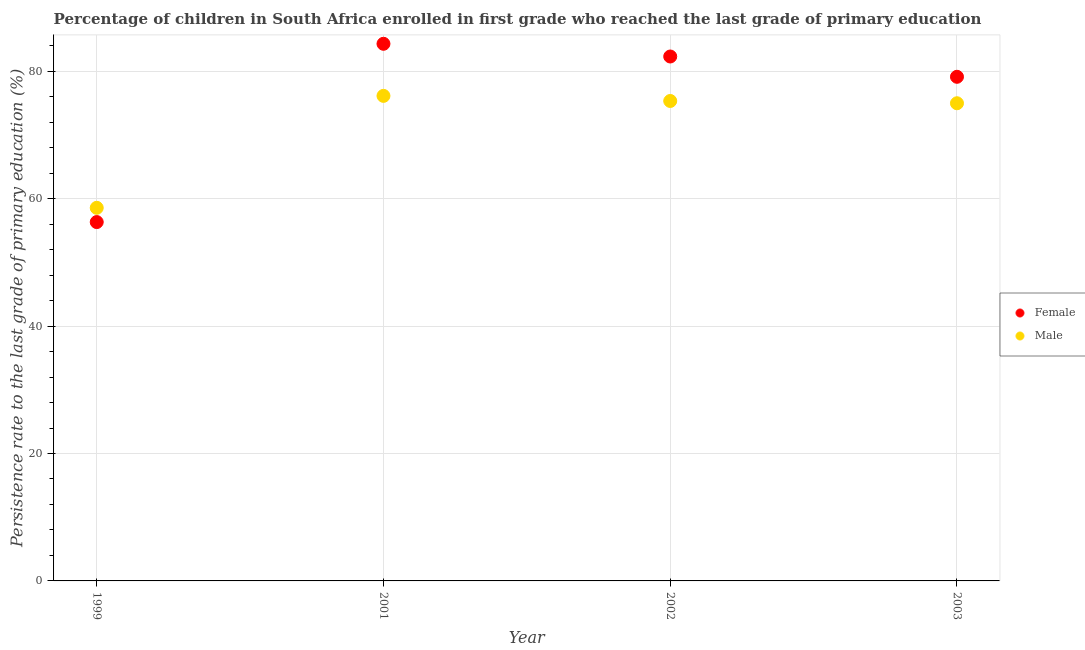How many different coloured dotlines are there?
Your answer should be very brief. 2. Is the number of dotlines equal to the number of legend labels?
Offer a terse response. Yes. What is the persistence rate of female students in 2001?
Your answer should be compact. 84.32. Across all years, what is the maximum persistence rate of female students?
Your response must be concise. 84.32. Across all years, what is the minimum persistence rate of female students?
Give a very brief answer. 56.33. What is the total persistence rate of male students in the graph?
Your answer should be very brief. 285.03. What is the difference between the persistence rate of male students in 2001 and that in 2002?
Give a very brief answer. 0.8. What is the difference between the persistence rate of male students in 1999 and the persistence rate of female students in 2002?
Your response must be concise. -23.75. What is the average persistence rate of male students per year?
Offer a very short reply. 71.26. In the year 2002, what is the difference between the persistence rate of female students and persistence rate of male students?
Provide a short and direct response. 6.98. What is the ratio of the persistence rate of female students in 1999 to that in 2001?
Provide a short and direct response. 0.67. Is the persistence rate of female students in 1999 less than that in 2001?
Your answer should be compact. Yes. Is the difference between the persistence rate of male students in 1999 and 2003 greater than the difference between the persistence rate of female students in 1999 and 2003?
Ensure brevity in your answer.  Yes. What is the difference between the highest and the second highest persistence rate of female students?
Your answer should be very brief. 2. What is the difference between the highest and the lowest persistence rate of male students?
Ensure brevity in your answer.  17.57. In how many years, is the persistence rate of female students greater than the average persistence rate of female students taken over all years?
Provide a succinct answer. 3. Is the persistence rate of female students strictly less than the persistence rate of male students over the years?
Give a very brief answer. No. What is the difference between two consecutive major ticks on the Y-axis?
Your response must be concise. 20. Are the values on the major ticks of Y-axis written in scientific E-notation?
Offer a terse response. No. Does the graph contain grids?
Your response must be concise. Yes. How many legend labels are there?
Your answer should be very brief. 2. How are the legend labels stacked?
Offer a terse response. Vertical. What is the title of the graph?
Your answer should be very brief. Percentage of children in South Africa enrolled in first grade who reached the last grade of primary education. Does "Male labor force" appear as one of the legend labels in the graph?
Make the answer very short. No. What is the label or title of the X-axis?
Provide a short and direct response. Year. What is the label or title of the Y-axis?
Offer a very short reply. Persistence rate to the last grade of primary education (%). What is the Persistence rate to the last grade of primary education (%) in Female in 1999?
Provide a succinct answer. 56.33. What is the Persistence rate to the last grade of primary education (%) of Male in 1999?
Offer a terse response. 58.57. What is the Persistence rate to the last grade of primary education (%) in Female in 2001?
Your answer should be compact. 84.32. What is the Persistence rate to the last grade of primary education (%) of Male in 2001?
Your answer should be very brief. 76.14. What is the Persistence rate to the last grade of primary education (%) of Female in 2002?
Your response must be concise. 82.32. What is the Persistence rate to the last grade of primary education (%) of Male in 2002?
Your answer should be compact. 75.34. What is the Persistence rate to the last grade of primary education (%) of Female in 2003?
Your answer should be compact. 79.13. What is the Persistence rate to the last grade of primary education (%) in Male in 2003?
Keep it short and to the point. 74.98. Across all years, what is the maximum Persistence rate to the last grade of primary education (%) of Female?
Provide a short and direct response. 84.32. Across all years, what is the maximum Persistence rate to the last grade of primary education (%) in Male?
Provide a succinct answer. 76.14. Across all years, what is the minimum Persistence rate to the last grade of primary education (%) in Female?
Provide a short and direct response. 56.33. Across all years, what is the minimum Persistence rate to the last grade of primary education (%) in Male?
Provide a short and direct response. 58.57. What is the total Persistence rate to the last grade of primary education (%) in Female in the graph?
Make the answer very short. 302.1. What is the total Persistence rate to the last grade of primary education (%) in Male in the graph?
Make the answer very short. 285.03. What is the difference between the Persistence rate to the last grade of primary education (%) in Female in 1999 and that in 2001?
Offer a terse response. -27.99. What is the difference between the Persistence rate to the last grade of primary education (%) of Male in 1999 and that in 2001?
Keep it short and to the point. -17.57. What is the difference between the Persistence rate to the last grade of primary education (%) of Female in 1999 and that in 2002?
Make the answer very short. -25.99. What is the difference between the Persistence rate to the last grade of primary education (%) of Male in 1999 and that in 2002?
Your answer should be compact. -16.77. What is the difference between the Persistence rate to the last grade of primary education (%) of Female in 1999 and that in 2003?
Give a very brief answer. -22.8. What is the difference between the Persistence rate to the last grade of primary education (%) in Male in 1999 and that in 2003?
Offer a very short reply. -16.41. What is the difference between the Persistence rate to the last grade of primary education (%) in Female in 2001 and that in 2002?
Your response must be concise. 2. What is the difference between the Persistence rate to the last grade of primary education (%) of Male in 2001 and that in 2002?
Make the answer very short. 0.8. What is the difference between the Persistence rate to the last grade of primary education (%) of Female in 2001 and that in 2003?
Give a very brief answer. 5.18. What is the difference between the Persistence rate to the last grade of primary education (%) of Male in 2001 and that in 2003?
Offer a terse response. 1.16. What is the difference between the Persistence rate to the last grade of primary education (%) in Female in 2002 and that in 2003?
Provide a short and direct response. 3.19. What is the difference between the Persistence rate to the last grade of primary education (%) of Male in 2002 and that in 2003?
Offer a very short reply. 0.36. What is the difference between the Persistence rate to the last grade of primary education (%) in Female in 1999 and the Persistence rate to the last grade of primary education (%) in Male in 2001?
Keep it short and to the point. -19.81. What is the difference between the Persistence rate to the last grade of primary education (%) in Female in 1999 and the Persistence rate to the last grade of primary education (%) in Male in 2002?
Your response must be concise. -19.01. What is the difference between the Persistence rate to the last grade of primary education (%) of Female in 1999 and the Persistence rate to the last grade of primary education (%) of Male in 2003?
Your answer should be very brief. -18.65. What is the difference between the Persistence rate to the last grade of primary education (%) of Female in 2001 and the Persistence rate to the last grade of primary education (%) of Male in 2002?
Make the answer very short. 8.98. What is the difference between the Persistence rate to the last grade of primary education (%) of Female in 2001 and the Persistence rate to the last grade of primary education (%) of Male in 2003?
Your response must be concise. 9.33. What is the difference between the Persistence rate to the last grade of primary education (%) in Female in 2002 and the Persistence rate to the last grade of primary education (%) in Male in 2003?
Your answer should be very brief. 7.34. What is the average Persistence rate to the last grade of primary education (%) of Female per year?
Offer a very short reply. 75.52. What is the average Persistence rate to the last grade of primary education (%) of Male per year?
Make the answer very short. 71.26. In the year 1999, what is the difference between the Persistence rate to the last grade of primary education (%) of Female and Persistence rate to the last grade of primary education (%) of Male?
Provide a short and direct response. -2.24. In the year 2001, what is the difference between the Persistence rate to the last grade of primary education (%) of Female and Persistence rate to the last grade of primary education (%) of Male?
Give a very brief answer. 8.18. In the year 2002, what is the difference between the Persistence rate to the last grade of primary education (%) in Female and Persistence rate to the last grade of primary education (%) in Male?
Your answer should be compact. 6.98. In the year 2003, what is the difference between the Persistence rate to the last grade of primary education (%) of Female and Persistence rate to the last grade of primary education (%) of Male?
Provide a succinct answer. 4.15. What is the ratio of the Persistence rate to the last grade of primary education (%) of Female in 1999 to that in 2001?
Offer a very short reply. 0.67. What is the ratio of the Persistence rate to the last grade of primary education (%) in Male in 1999 to that in 2001?
Offer a terse response. 0.77. What is the ratio of the Persistence rate to the last grade of primary education (%) in Female in 1999 to that in 2002?
Offer a very short reply. 0.68. What is the ratio of the Persistence rate to the last grade of primary education (%) of Male in 1999 to that in 2002?
Provide a short and direct response. 0.78. What is the ratio of the Persistence rate to the last grade of primary education (%) of Female in 1999 to that in 2003?
Ensure brevity in your answer.  0.71. What is the ratio of the Persistence rate to the last grade of primary education (%) of Male in 1999 to that in 2003?
Your answer should be very brief. 0.78. What is the ratio of the Persistence rate to the last grade of primary education (%) in Female in 2001 to that in 2002?
Provide a short and direct response. 1.02. What is the ratio of the Persistence rate to the last grade of primary education (%) in Male in 2001 to that in 2002?
Offer a terse response. 1.01. What is the ratio of the Persistence rate to the last grade of primary education (%) of Female in 2001 to that in 2003?
Offer a very short reply. 1.07. What is the ratio of the Persistence rate to the last grade of primary education (%) in Male in 2001 to that in 2003?
Give a very brief answer. 1.02. What is the ratio of the Persistence rate to the last grade of primary education (%) in Female in 2002 to that in 2003?
Provide a succinct answer. 1.04. What is the difference between the highest and the second highest Persistence rate to the last grade of primary education (%) in Female?
Give a very brief answer. 2. What is the difference between the highest and the second highest Persistence rate to the last grade of primary education (%) in Male?
Ensure brevity in your answer.  0.8. What is the difference between the highest and the lowest Persistence rate to the last grade of primary education (%) in Female?
Ensure brevity in your answer.  27.99. What is the difference between the highest and the lowest Persistence rate to the last grade of primary education (%) in Male?
Keep it short and to the point. 17.57. 